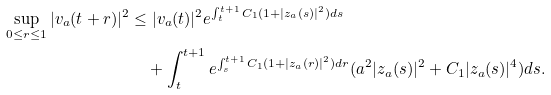<formula> <loc_0><loc_0><loc_500><loc_500>\sup _ { 0 \leq r \leq 1 } | v _ { a } ( t + r ) | ^ { 2 } & \leq | v _ { a } ( t ) | ^ { 2 } e ^ { \int _ { t } ^ { t + 1 } C _ { 1 } ( 1 + | z _ { a } ( s ) | ^ { 2 } ) d s } \\ & \quad + \int _ { t } ^ { t + 1 } e ^ { \int _ { s } ^ { t + 1 } C _ { 1 } ( 1 + | z _ { a } ( r ) | ^ { 2 } ) d r } ( a ^ { 2 } | z _ { a } ( s ) | ^ { 2 } + C _ { 1 } | z _ { a } ( s ) | ^ { 4 } ) d s .</formula> 